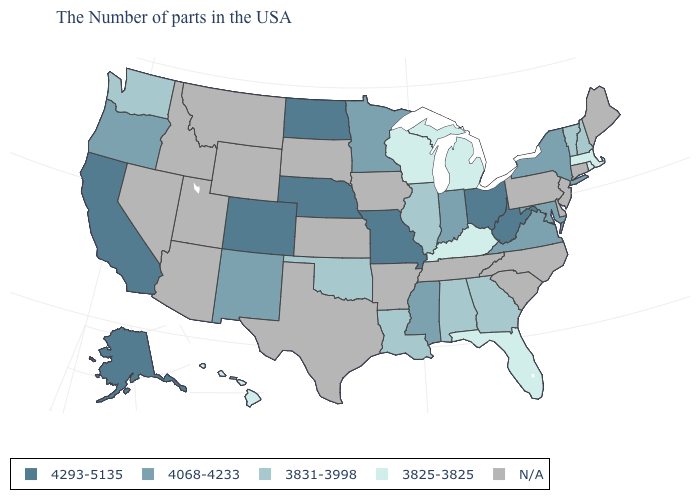Does New York have the highest value in the Northeast?
Keep it brief. Yes. Which states hav the highest value in the West?
Concise answer only. Colorado, California, Alaska. Is the legend a continuous bar?
Give a very brief answer. No. Name the states that have a value in the range N/A?
Concise answer only. Maine, Connecticut, New Jersey, Delaware, Pennsylvania, North Carolina, South Carolina, Tennessee, Arkansas, Iowa, Kansas, Texas, South Dakota, Wyoming, Utah, Montana, Arizona, Idaho, Nevada. What is the value of Colorado?
Concise answer only. 4293-5135. Does New Hampshire have the highest value in the USA?
Short answer required. No. Does the first symbol in the legend represent the smallest category?
Quick response, please. No. Name the states that have a value in the range 4068-4233?
Write a very short answer. New York, Maryland, Virginia, Indiana, Mississippi, Minnesota, New Mexico, Oregon. What is the value of North Carolina?
Be succinct. N/A. Among the states that border Utah , which have the lowest value?
Give a very brief answer. New Mexico. Name the states that have a value in the range 3831-3998?
Answer briefly. New Hampshire, Vermont, Georgia, Alabama, Illinois, Louisiana, Oklahoma, Washington. Does the map have missing data?
Concise answer only. Yes. What is the lowest value in states that border Wyoming?
Be succinct. 4293-5135. What is the value of Missouri?
Give a very brief answer. 4293-5135. 